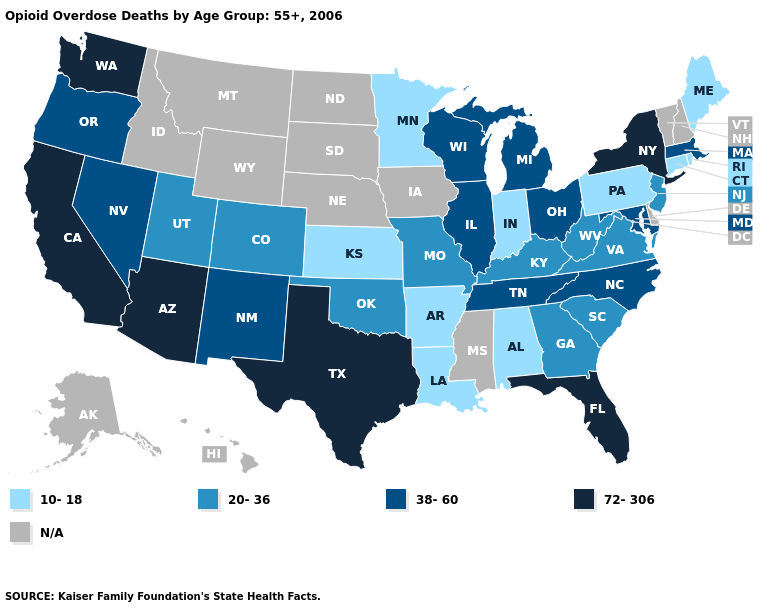What is the lowest value in the USA?
Give a very brief answer. 10-18. Which states have the lowest value in the West?
Give a very brief answer. Colorado, Utah. What is the highest value in the Northeast ?
Write a very short answer. 72-306. Name the states that have a value in the range 38-60?
Give a very brief answer. Illinois, Maryland, Massachusetts, Michigan, Nevada, New Mexico, North Carolina, Ohio, Oregon, Tennessee, Wisconsin. What is the value of Colorado?
Write a very short answer. 20-36. Does Illinois have the lowest value in the USA?
Quick response, please. No. Name the states that have a value in the range 38-60?
Give a very brief answer. Illinois, Maryland, Massachusetts, Michigan, Nevada, New Mexico, North Carolina, Ohio, Oregon, Tennessee, Wisconsin. Name the states that have a value in the range 10-18?
Keep it brief. Alabama, Arkansas, Connecticut, Indiana, Kansas, Louisiana, Maine, Minnesota, Pennsylvania, Rhode Island. Does the first symbol in the legend represent the smallest category?
Give a very brief answer. Yes. What is the value of South Dakota?
Short answer required. N/A. Name the states that have a value in the range N/A?
Keep it brief. Alaska, Delaware, Hawaii, Idaho, Iowa, Mississippi, Montana, Nebraska, New Hampshire, North Dakota, South Dakota, Vermont, Wyoming. Does the first symbol in the legend represent the smallest category?
Give a very brief answer. Yes. Does Louisiana have the lowest value in the South?
Answer briefly. Yes. Does the map have missing data?
Short answer required. Yes. 